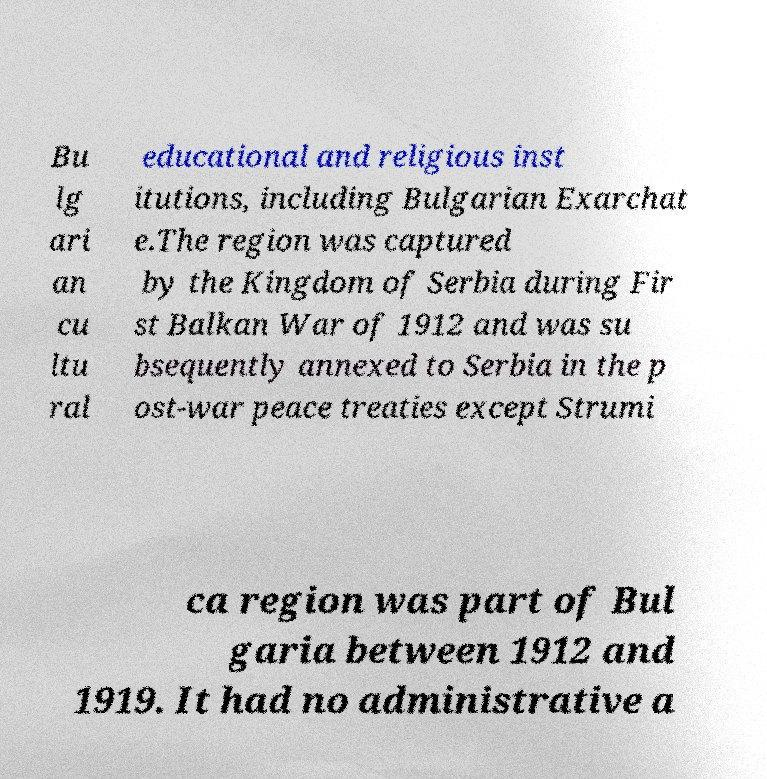Please identify and transcribe the text found in this image. Bu lg ari an cu ltu ral educational and religious inst itutions, including Bulgarian Exarchat e.The region was captured by the Kingdom of Serbia during Fir st Balkan War of 1912 and was su bsequently annexed to Serbia in the p ost-war peace treaties except Strumi ca region was part of Bul garia between 1912 and 1919. It had no administrative a 